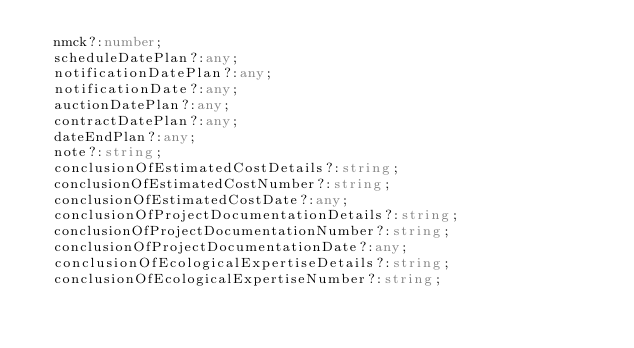<code> <loc_0><loc_0><loc_500><loc_500><_TypeScript_>  nmck?:number;
  scheduleDatePlan?:any;
  notificationDatePlan?:any;
  notificationDate?:any;
  auctionDatePlan?:any;
  contractDatePlan?:any;
  dateEndPlan?:any;
  note?:string;
  conclusionOfEstimatedCostDetails?:string;
  conclusionOfEstimatedCostNumber?:string;
  conclusionOfEstimatedCostDate?:any;
  conclusionOfProjectDocumentationDetails?:string;
  conclusionOfProjectDocumentationNumber?:string;
  conclusionOfProjectDocumentationDate?:any;
  conclusionOfEcologicalExpertiseDetails?:string;
  conclusionOfEcologicalExpertiseNumber?:string;</code> 